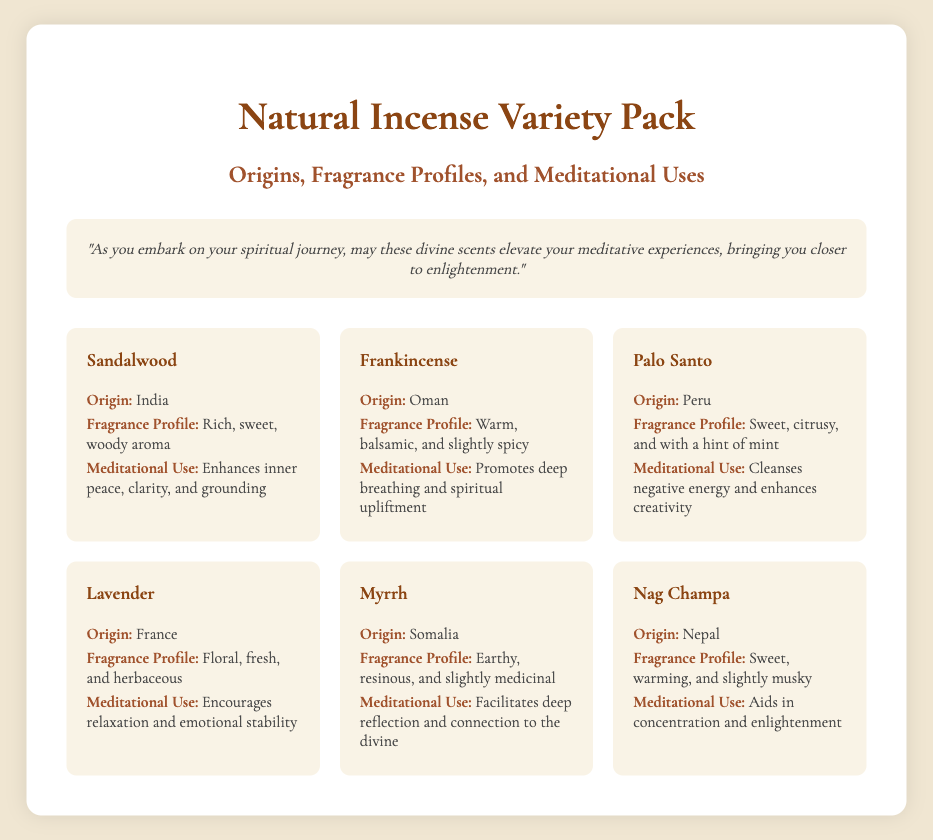What is the title of the document? The title of the document is displayed prominently at the top, indicative of the product being introduced.
Answer: Natural Incense Variety Pack What is the origin of Sandalwood? The document states the origins of each incense type, with Sandalwood originating from India.
Answer: India What is the fragrance profile of Frankincense? The fragrance profile is described for each incense, with Frankincense having a warm, balsamic, and slightly spicy aroma.
Answer: Warm, balsamic, and slightly spicy What meditational use is associated with Lavender? Each incense has a designated meditational use listed, with Lavender encouraging relaxation and emotional stability.
Answer: Encourages relaxation and emotional stability Which incense originates from Peru? The document lists the origins of each type, with Palo Santo specifically mentioned as originating from Peru.
Answer: Palo Santo How many incense types are listed in the document? The document contains a grid display of the incense items, and there are six types listed in total.
Answer: Six What is the fragrance profile of Nag Champa? The fragrance profile is outlined in the document for each incense, and Nag Champa is described as sweet, warming, and slightly musky.
Answer: Sweet, warming, and slightly musky Which incense is associated with spiritual upliftment? The document associates meditational uses with each incense, and Frankincense is mentioned for promoting deep breathing and spiritual upliftment.
Answer: Frankincense What is the monk's message in the document? A message from the monk is shared in a styled section, emphasizing the spiritual journey and the role of scents.
Answer: "As you embark on your spiritual journey, may these divine scents elevate your meditative experiences, bringing you closer to enlightenment." 